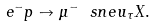<formula> <loc_0><loc_0><loc_500><loc_500>e ^ { - } p \to \mu ^ { - } \ s n e u _ { \tau } X .</formula> 